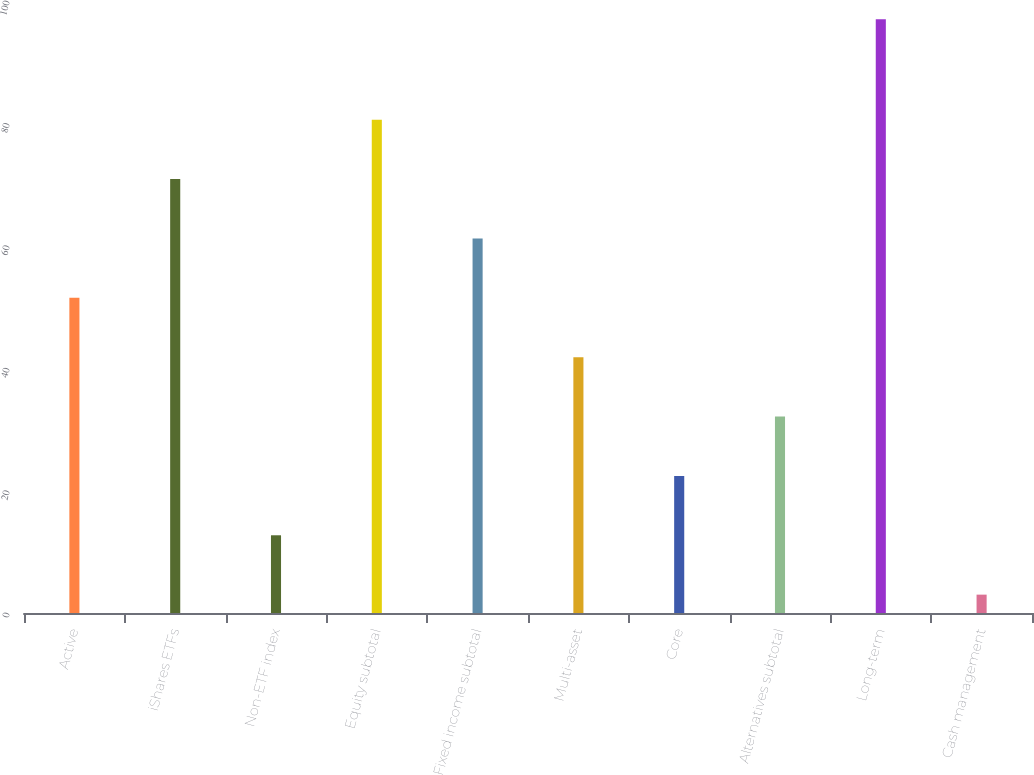Convert chart to OTSL. <chart><loc_0><loc_0><loc_500><loc_500><bar_chart><fcel>Active<fcel>iShares ETFs<fcel>Non-ETF index<fcel>Equity subtotal<fcel>Fixed income subtotal<fcel>Multi-asset<fcel>Core<fcel>Alternatives subtotal<fcel>Long-term<fcel>Cash management<nl><fcel>51.5<fcel>70.9<fcel>12.7<fcel>80.6<fcel>61.2<fcel>41.8<fcel>22.4<fcel>32.1<fcel>97<fcel>3<nl></chart> 